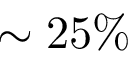Convert formula to latex. <formula><loc_0><loc_0><loc_500><loc_500>\sim 2 5 \%</formula> 